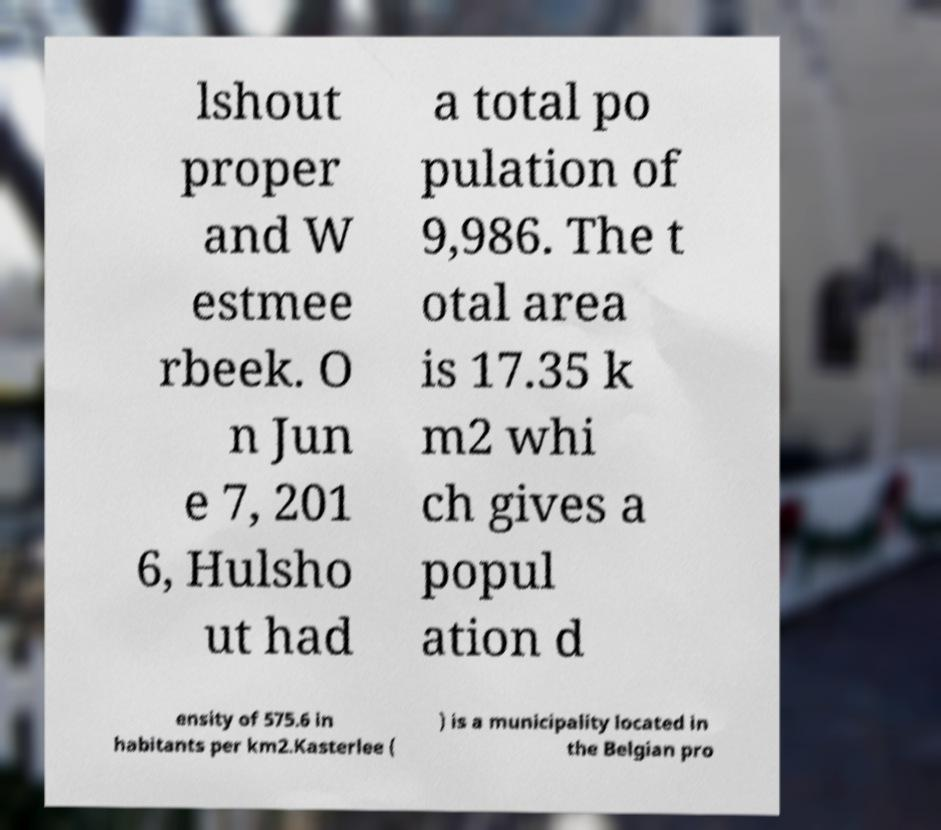Could you assist in decoding the text presented in this image and type it out clearly? lshout proper and W estmee rbeek. O n Jun e 7, 201 6, Hulsho ut had a total po pulation of 9,986. The t otal area is 17.35 k m2 whi ch gives a popul ation d ensity of 575.6 in habitants per km2.Kasterlee ( ) is a municipality located in the Belgian pro 